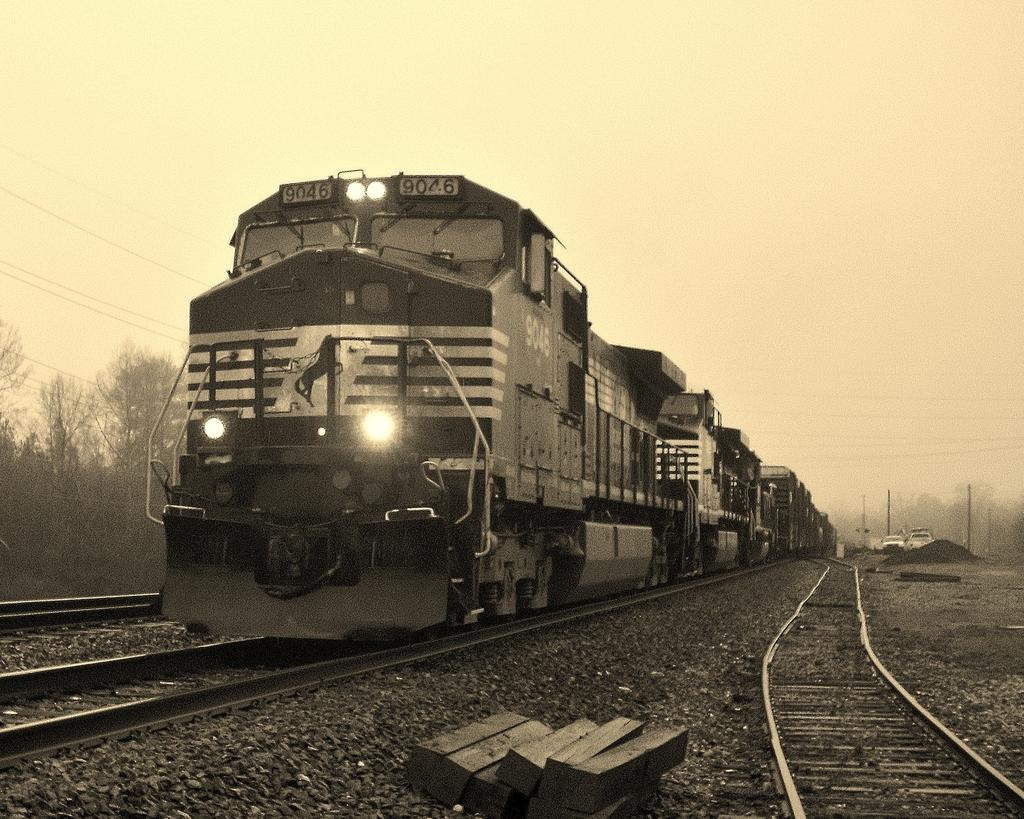What is the main subject of the image? The main subject of the image is a train. What can be seen alongside the train in the image? There are railway tracks in the image. What other vehicles are present in the image? There are cars in the image. What structures can be seen near the railway tracks? There are current poles in the image. What type of natural scenery is visible in the image? There are trees in the image. What is visible in the background of the image? The sky is visible in the image. What is the cent of the image? There is no cent present in the image, as it is a unit of measurement and not a visual element. 